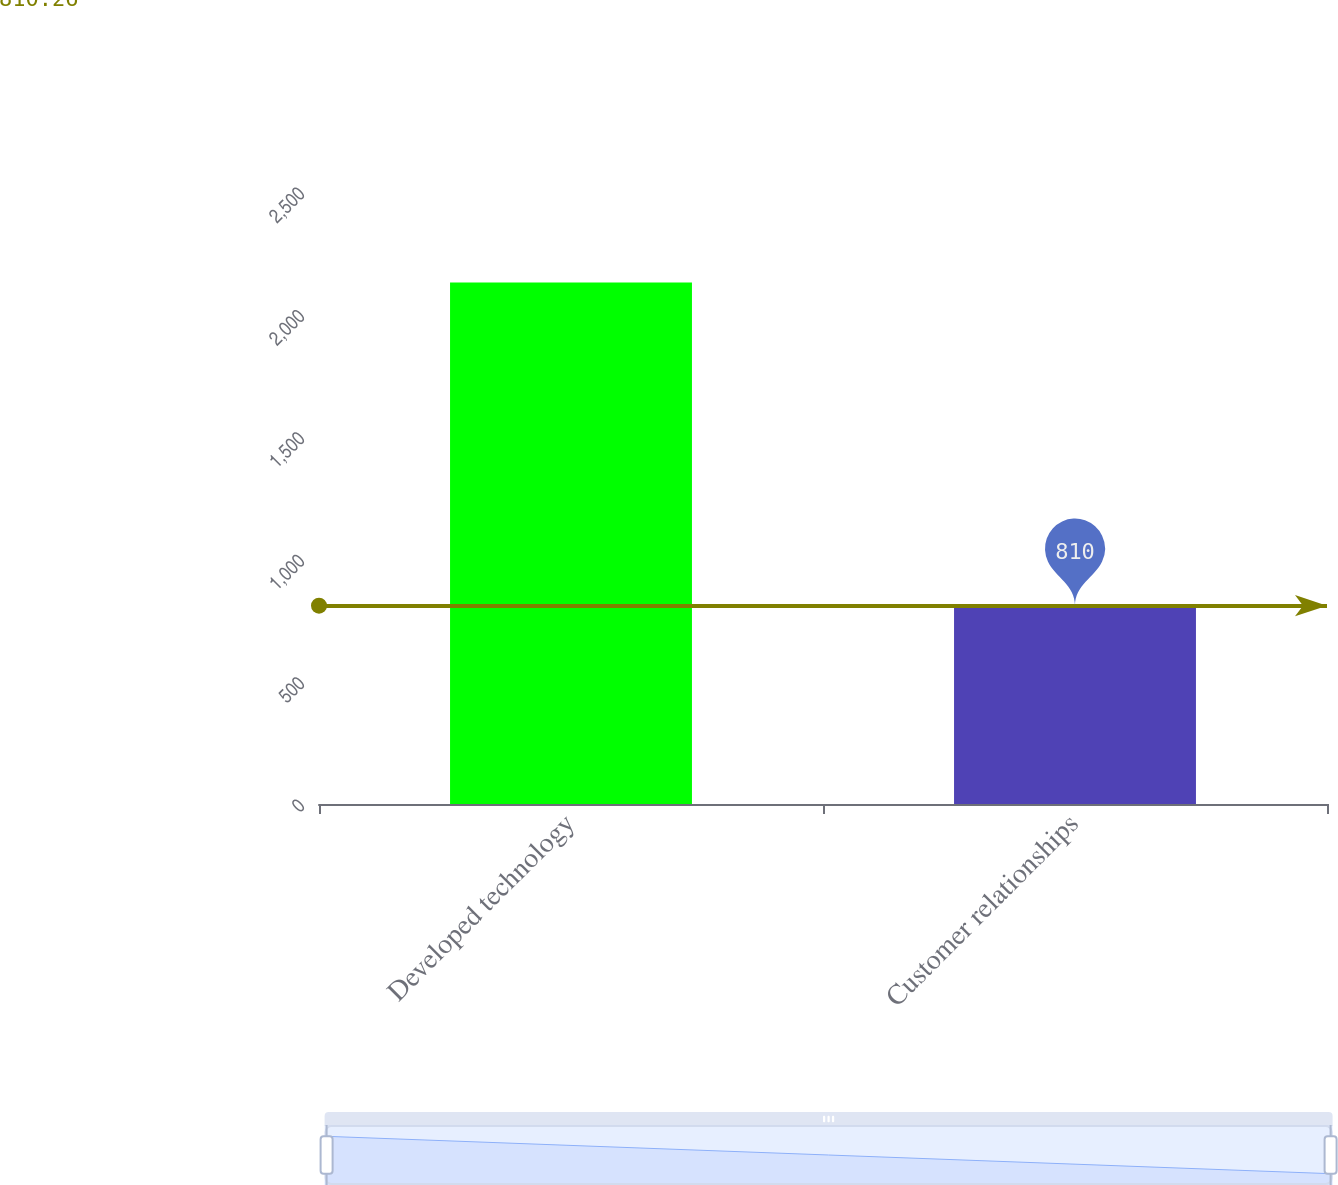Convert chart to OTSL. <chart><loc_0><loc_0><loc_500><loc_500><bar_chart><fcel>Developed technology<fcel>Customer relationships<nl><fcel>2130<fcel>810<nl></chart> 